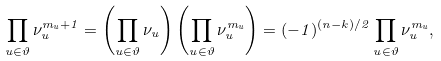Convert formula to latex. <formula><loc_0><loc_0><loc_500><loc_500>\prod _ { u \in \vartheta } \nu _ { u } ^ { m _ { u } + 1 } = \left ( \prod _ { u \in \vartheta } \nu _ { u } \right ) \left ( \prod _ { u \in \vartheta } \nu _ { u } ^ { m _ { u } } \right ) = ( - 1 ) ^ { ( n - k ) / 2 } \prod _ { u \in \vartheta } \nu _ { u } ^ { m _ { u } } ,</formula> 